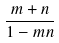Convert formula to latex. <formula><loc_0><loc_0><loc_500><loc_500>\frac { m + n } { 1 - m n }</formula> 